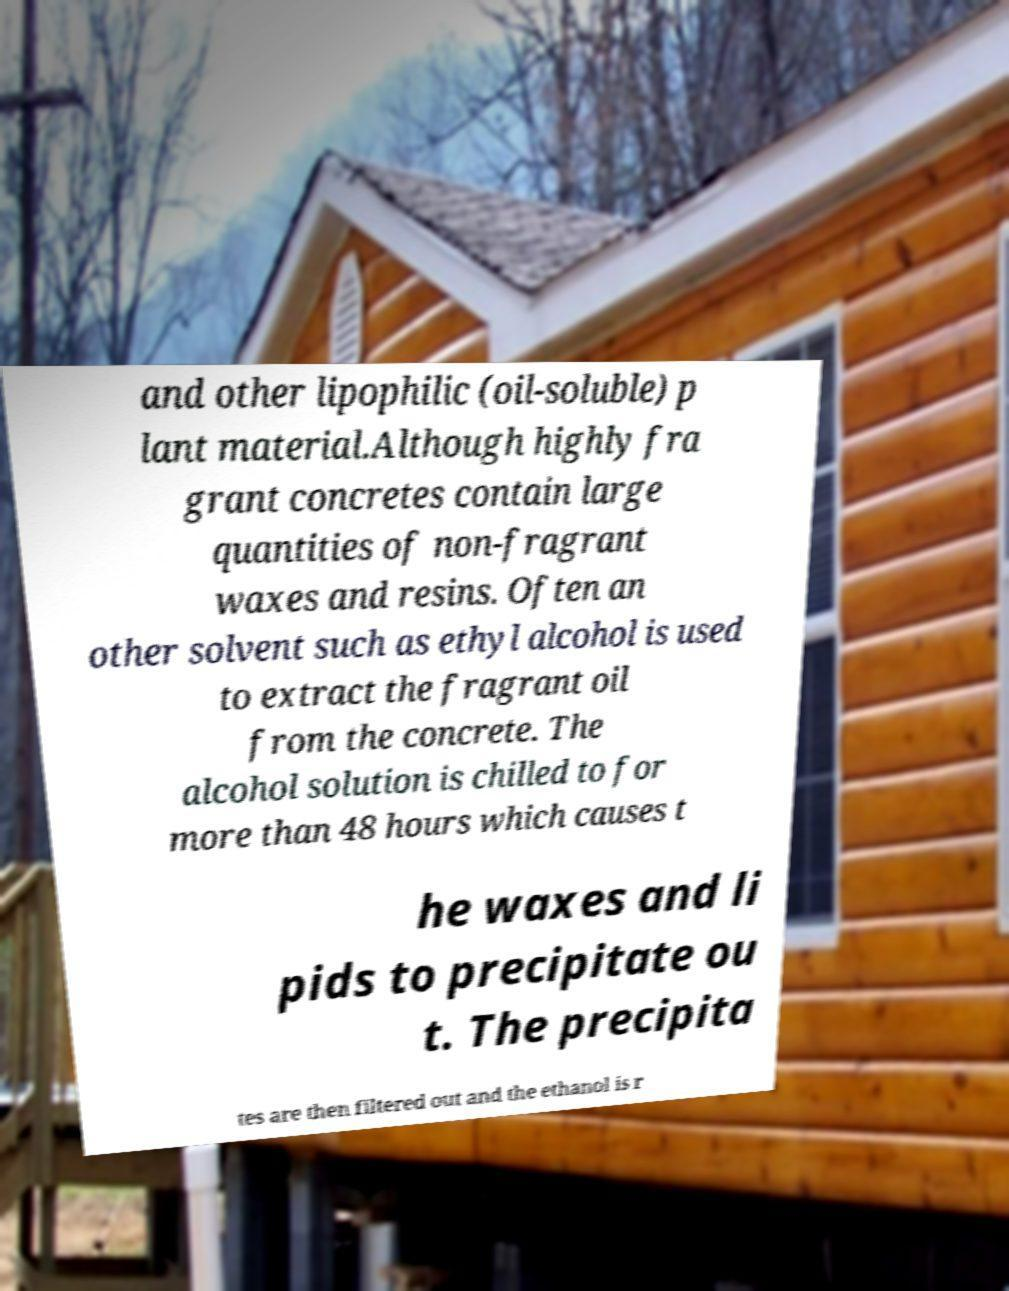Can you accurately transcribe the text from the provided image for me? and other lipophilic (oil-soluble) p lant material.Although highly fra grant concretes contain large quantities of non-fragrant waxes and resins. Often an other solvent such as ethyl alcohol is used to extract the fragrant oil from the concrete. The alcohol solution is chilled to for more than 48 hours which causes t he waxes and li pids to precipitate ou t. The precipita tes are then filtered out and the ethanol is r 